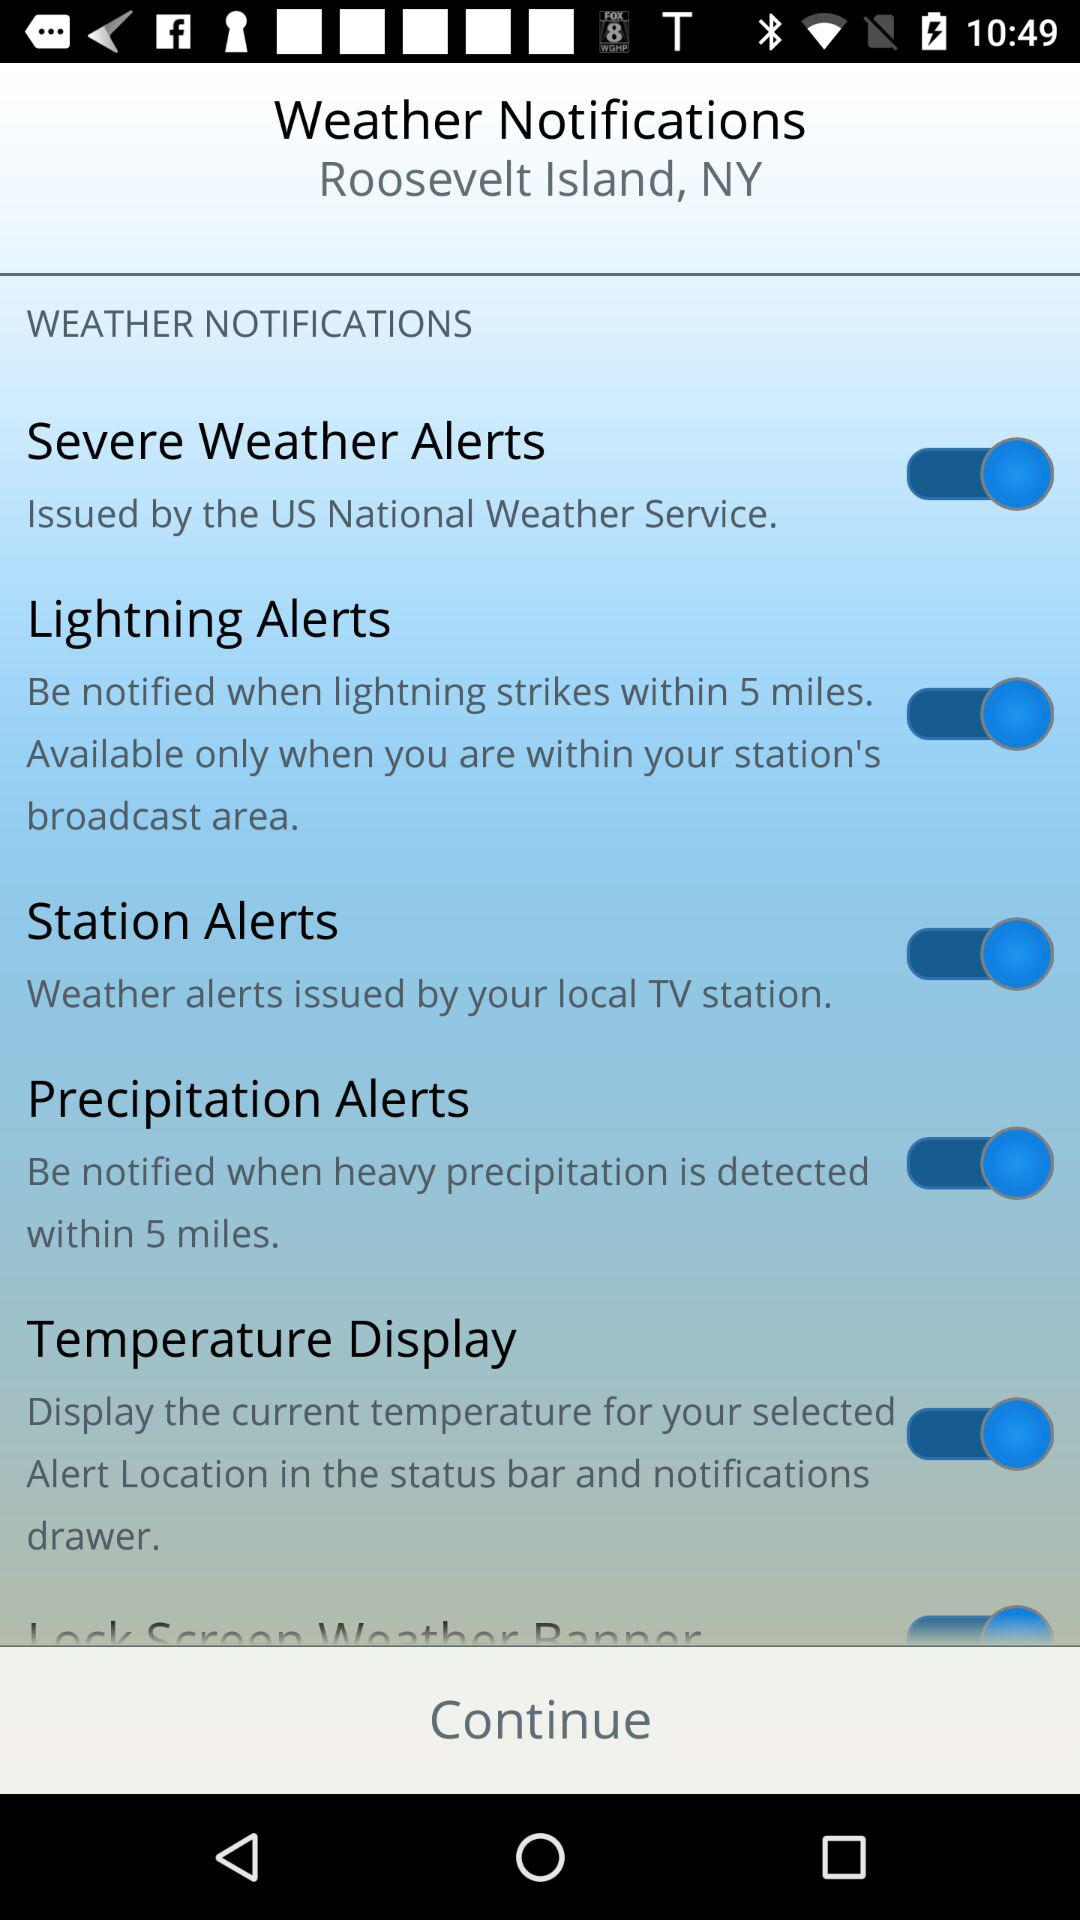What is the status of the "Severe Weather Alerts" notification setting? The status of the "Severe Weather Alerts" notification setting is "on". 